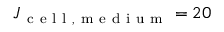Convert formula to latex. <formula><loc_0><loc_0><loc_500><loc_500>J _ { c e l l , m e d i u m } = 2 0</formula> 